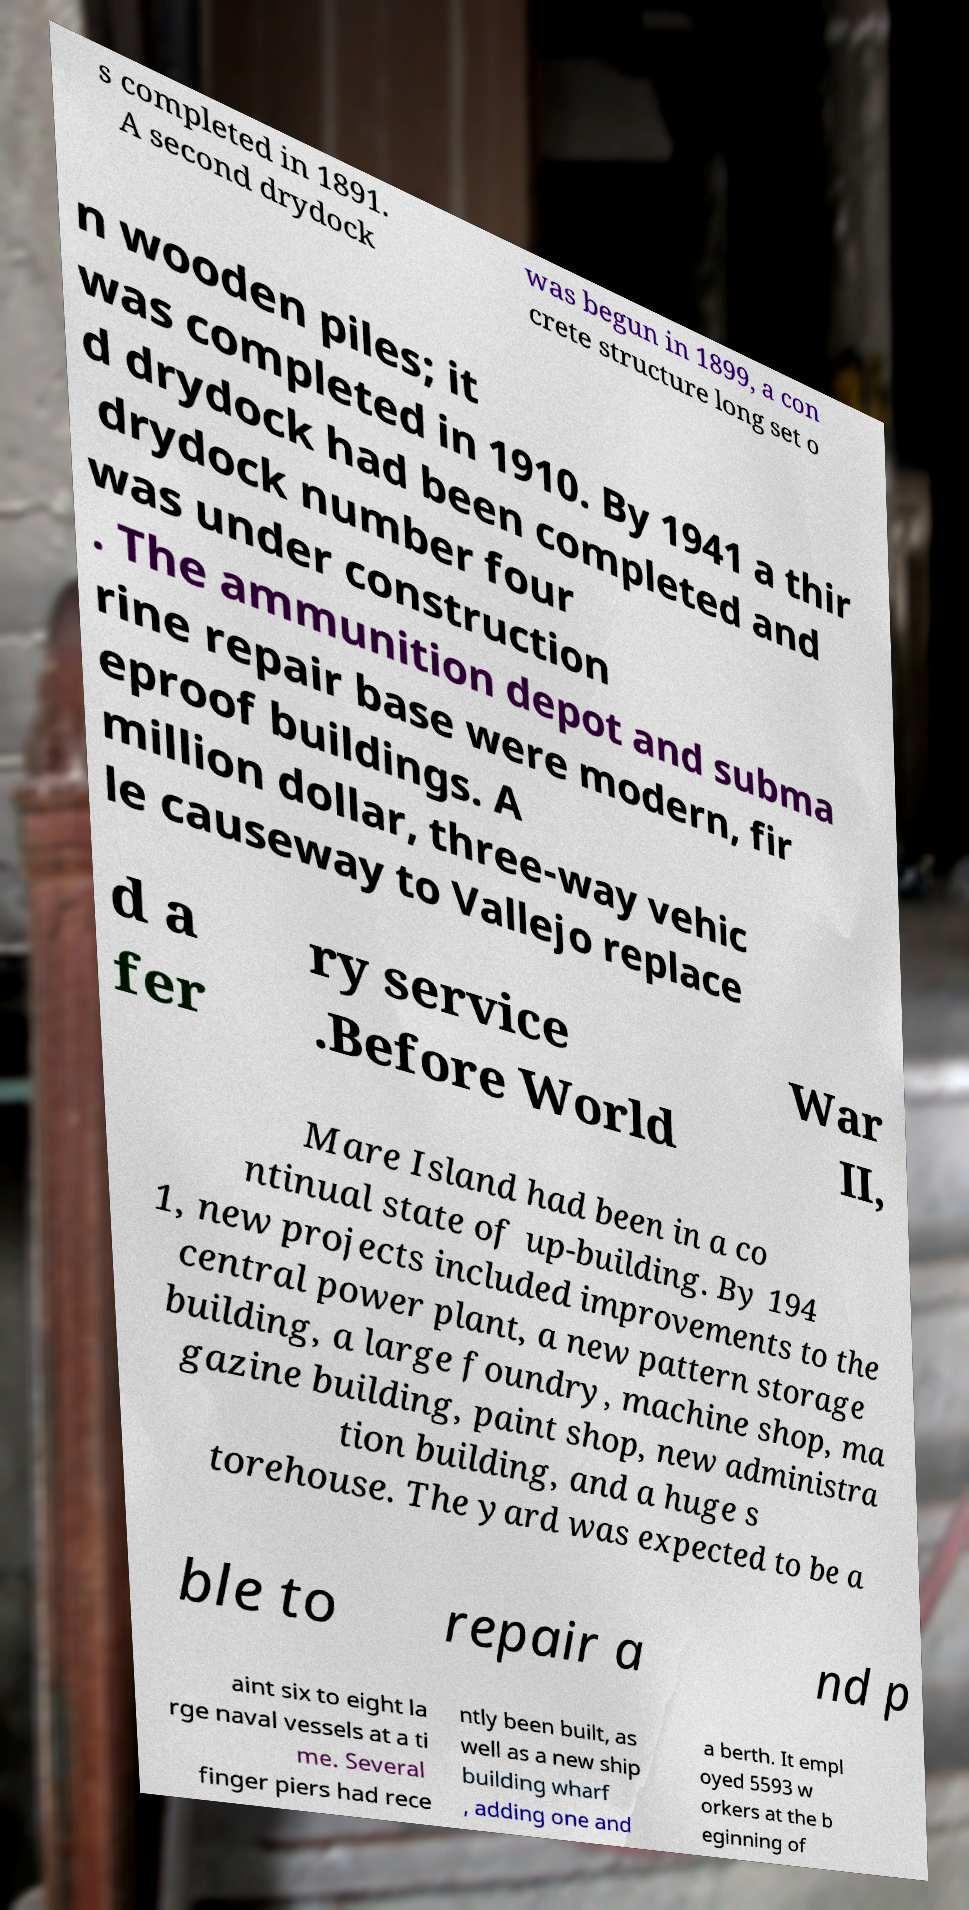Please identify and transcribe the text found in this image. s completed in 1891. A second drydock was begun in 1899, a con crete structure long set o n wooden piles; it was completed in 1910. By 1941 a thir d drydock had been completed and drydock number four was under construction . The ammunition depot and subma rine repair base were modern, fir eproof buildings. A million dollar, three-way vehic le causeway to Vallejo replace d a fer ry service .Before World War II, Mare Island had been in a co ntinual state of up-building. By 194 1, new projects included improvements to the central power plant, a new pattern storage building, a large foundry, machine shop, ma gazine building, paint shop, new administra tion building, and a huge s torehouse. The yard was expected to be a ble to repair a nd p aint six to eight la rge naval vessels at a ti me. Several finger piers had rece ntly been built, as well as a new ship building wharf , adding one and a berth. It empl oyed 5593 w orkers at the b eginning of 